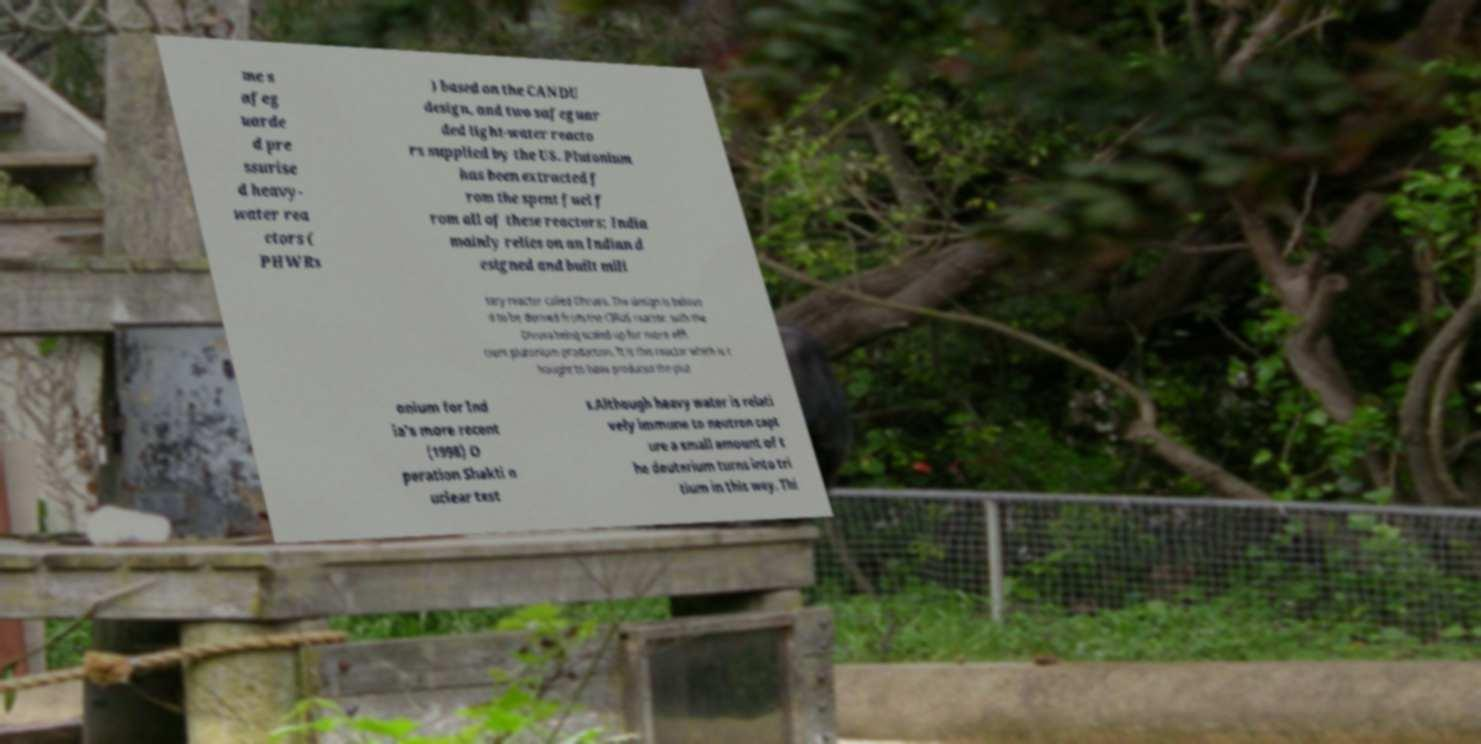Could you extract and type out the text from this image? me s afeg uarde d pre ssurise d heavy- water rea ctors ( PHWRs ) based on the CANDU design, and two safeguar ded light-water reacto rs supplied by the US. Plutonium has been extracted f rom the spent fuel f rom all of these reactors; India mainly relies on an Indian d esigned and built mili tary reactor called Dhruva. The design is believe d to be derived from the CIRUS reactor, with the Dhruva being scaled-up for more effi cient plutonium production. It is this reactor which is t hought to have produced the plut onium for Ind ia's more recent (1998) O peration Shakti n uclear test s.Although heavy water is relati vely immune to neutron capt ure a small amount of t he deuterium turns into tri tium in this way. Thi 